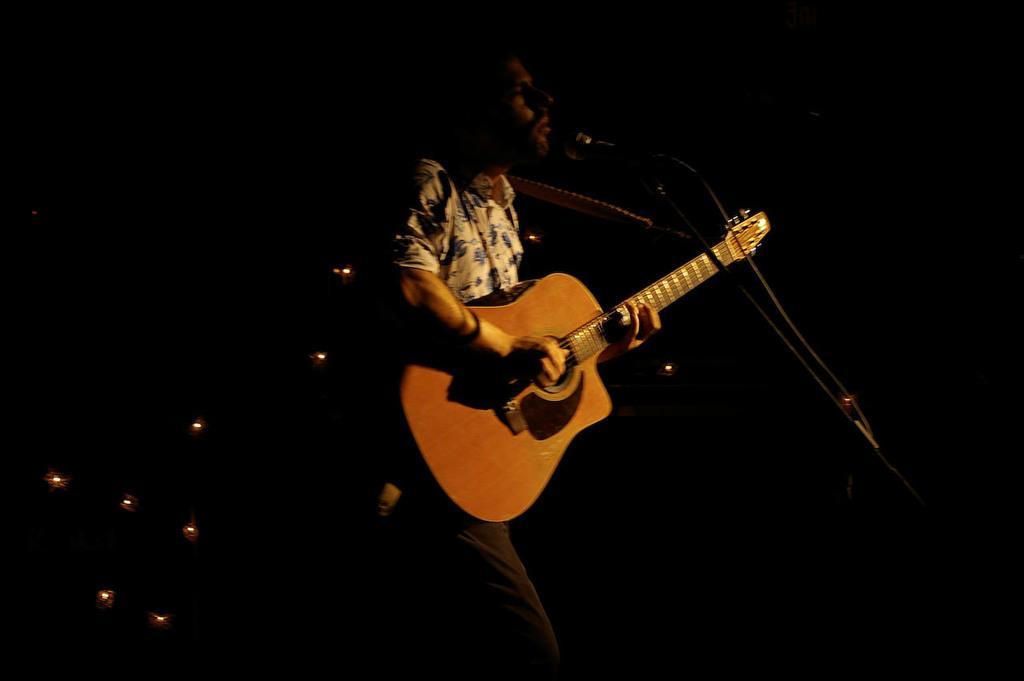Could you give a brief overview of what you see in this image? In this image i can see a person singing in front of a micro phone and playing a guitar at the back ground i can see few lights. 